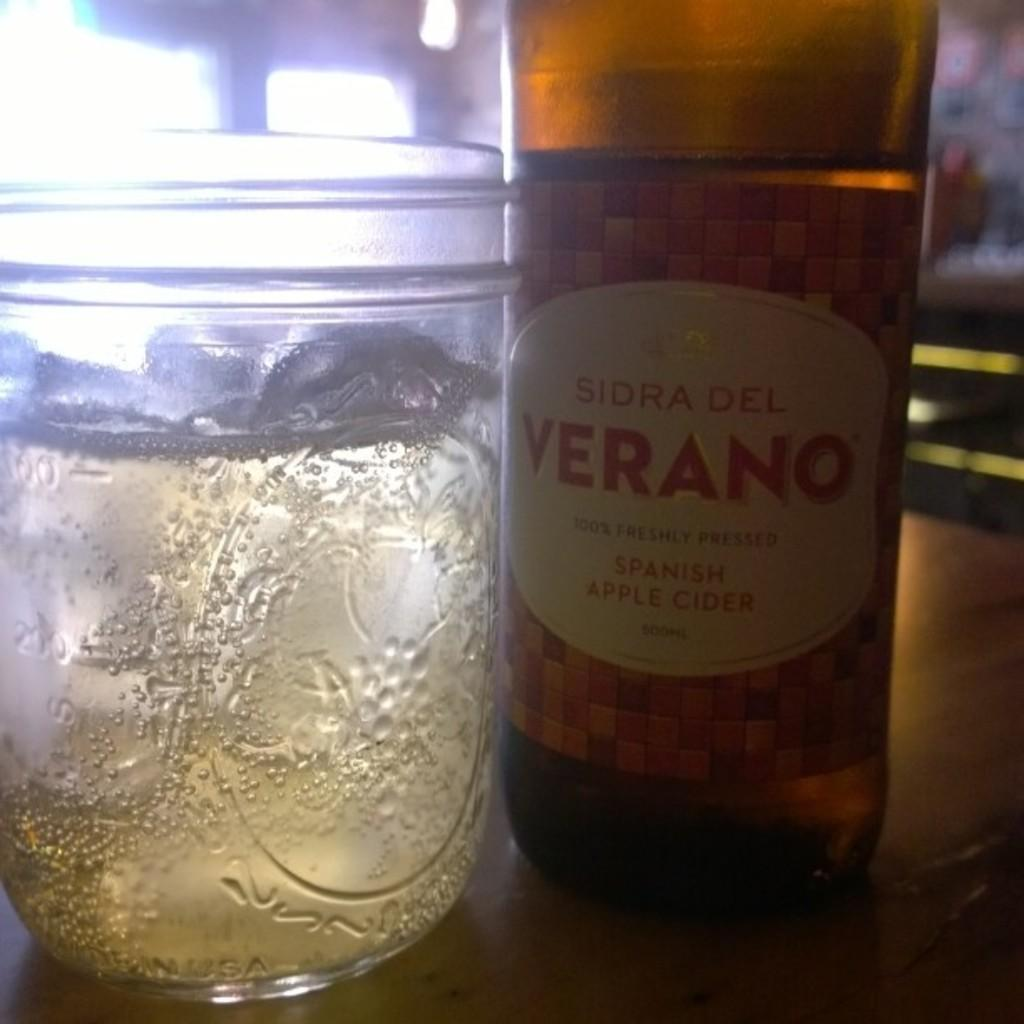What type of beverage container is present in the image? There is a wine bottle in the image. What is the wine bottle accompanied by? There is a glass in the image. Where are the wine bottle and glass located? Both the wine bottle and the glass are on a table. What type of tin can be seen in the image? There is no tin present in the image; it features a wine bottle and a glass on a table. 